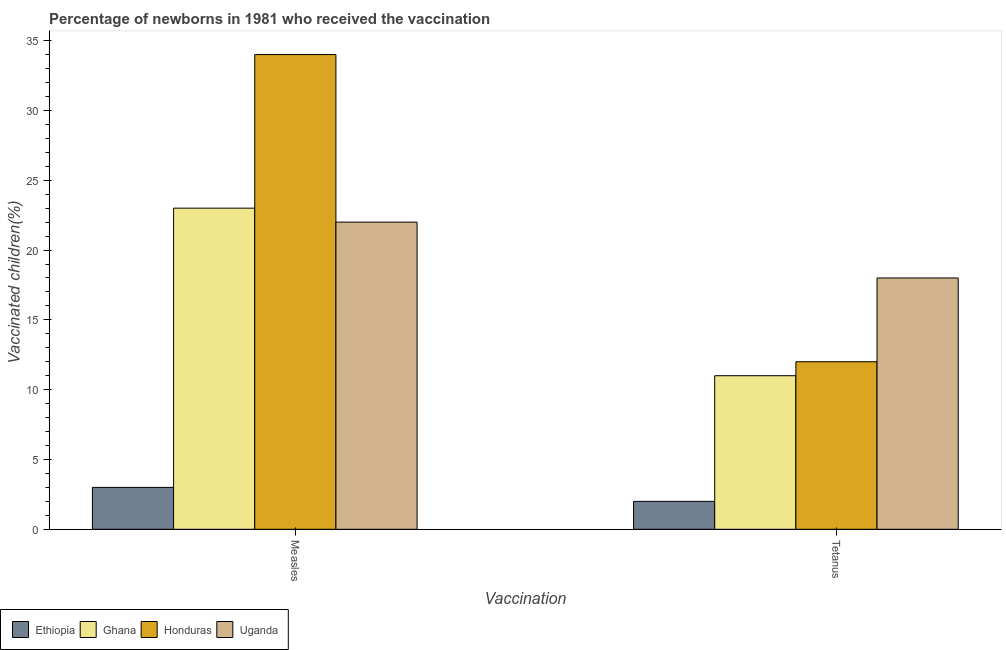How many different coloured bars are there?
Your answer should be compact. 4. Are the number of bars on each tick of the X-axis equal?
Provide a succinct answer. Yes. How many bars are there on the 2nd tick from the right?
Ensure brevity in your answer.  4. What is the label of the 1st group of bars from the left?
Offer a very short reply. Measles. What is the percentage of newborns who received vaccination for tetanus in Uganda?
Offer a very short reply. 18. Across all countries, what is the maximum percentage of newborns who received vaccination for tetanus?
Keep it short and to the point. 18. Across all countries, what is the minimum percentage of newborns who received vaccination for measles?
Your answer should be compact. 3. In which country was the percentage of newborns who received vaccination for measles maximum?
Keep it short and to the point. Honduras. In which country was the percentage of newborns who received vaccination for tetanus minimum?
Your response must be concise. Ethiopia. What is the total percentage of newborns who received vaccination for tetanus in the graph?
Offer a terse response. 43. What is the difference between the percentage of newborns who received vaccination for measles in Ethiopia and that in Ghana?
Your answer should be very brief. -20. What is the difference between the percentage of newborns who received vaccination for measles in Uganda and the percentage of newborns who received vaccination for tetanus in Honduras?
Provide a short and direct response. 10. What is the average percentage of newborns who received vaccination for measles per country?
Provide a succinct answer. 20.5. What is the difference between the percentage of newborns who received vaccination for measles and percentage of newborns who received vaccination for tetanus in Ghana?
Offer a very short reply. 12. What is the ratio of the percentage of newborns who received vaccination for measles in Honduras to that in Ethiopia?
Offer a very short reply. 11.33. Is the percentage of newborns who received vaccination for tetanus in Honduras less than that in Ghana?
Give a very brief answer. No. What does the 1st bar from the left in Tetanus represents?
Ensure brevity in your answer.  Ethiopia. What does the 2nd bar from the right in Measles represents?
Your answer should be very brief. Honduras. How many bars are there?
Offer a terse response. 8. What is the difference between two consecutive major ticks on the Y-axis?
Offer a very short reply. 5. How are the legend labels stacked?
Give a very brief answer. Horizontal. What is the title of the graph?
Ensure brevity in your answer.  Percentage of newborns in 1981 who received the vaccination. Does "Equatorial Guinea" appear as one of the legend labels in the graph?
Offer a terse response. No. What is the label or title of the X-axis?
Keep it short and to the point. Vaccination. What is the label or title of the Y-axis?
Keep it short and to the point. Vaccinated children(%)
. What is the Vaccinated children(%)
 in Ghana in Measles?
Give a very brief answer. 23. What is the Vaccinated children(%)
 in Uganda in Measles?
Your response must be concise. 22. What is the Vaccinated children(%)
 in Ethiopia in Tetanus?
Your answer should be very brief. 2. What is the Vaccinated children(%)
 in Honduras in Tetanus?
Offer a terse response. 12. Across all Vaccination, what is the maximum Vaccinated children(%)
 of Honduras?
Make the answer very short. 34. Across all Vaccination, what is the minimum Vaccinated children(%)
 in Ethiopia?
Give a very brief answer. 2. What is the total Vaccinated children(%)
 in Ethiopia in the graph?
Offer a terse response. 5. What is the total Vaccinated children(%)
 in Uganda in the graph?
Your answer should be compact. 40. What is the difference between the Vaccinated children(%)
 in Ethiopia in Measles and that in Tetanus?
Make the answer very short. 1. What is the difference between the Vaccinated children(%)
 in Ghana in Measles and that in Tetanus?
Make the answer very short. 12. What is the difference between the Vaccinated children(%)
 of Honduras in Measles and that in Tetanus?
Give a very brief answer. 22. What is the difference between the Vaccinated children(%)
 of Ethiopia in Measles and the Vaccinated children(%)
 of Ghana in Tetanus?
Make the answer very short. -8. What is the difference between the Vaccinated children(%)
 in Ethiopia in Measles and the Vaccinated children(%)
 in Honduras in Tetanus?
Give a very brief answer. -9. What is the difference between the Vaccinated children(%)
 in Ghana in Measles and the Vaccinated children(%)
 in Honduras in Tetanus?
Offer a terse response. 11. What is the difference between the Vaccinated children(%)
 of Ghana in Measles and the Vaccinated children(%)
 of Uganda in Tetanus?
Offer a very short reply. 5. What is the difference between the Vaccinated children(%)
 in Ethiopia and Vaccinated children(%)
 in Ghana in Measles?
Your answer should be very brief. -20. What is the difference between the Vaccinated children(%)
 of Ethiopia and Vaccinated children(%)
 of Honduras in Measles?
Provide a short and direct response. -31. What is the difference between the Vaccinated children(%)
 in Honduras and Vaccinated children(%)
 in Uganda in Measles?
Provide a succinct answer. 12. What is the difference between the Vaccinated children(%)
 of Ghana and Vaccinated children(%)
 of Honduras in Tetanus?
Ensure brevity in your answer.  -1. What is the ratio of the Vaccinated children(%)
 of Ethiopia in Measles to that in Tetanus?
Ensure brevity in your answer.  1.5. What is the ratio of the Vaccinated children(%)
 in Ghana in Measles to that in Tetanus?
Offer a very short reply. 2.09. What is the ratio of the Vaccinated children(%)
 of Honduras in Measles to that in Tetanus?
Give a very brief answer. 2.83. What is the ratio of the Vaccinated children(%)
 of Uganda in Measles to that in Tetanus?
Make the answer very short. 1.22. What is the difference between the highest and the second highest Vaccinated children(%)
 of Ethiopia?
Ensure brevity in your answer.  1. What is the difference between the highest and the second highest Vaccinated children(%)
 of Ghana?
Provide a succinct answer. 12. What is the difference between the highest and the second highest Vaccinated children(%)
 of Uganda?
Make the answer very short. 4. What is the difference between the highest and the lowest Vaccinated children(%)
 of Uganda?
Offer a very short reply. 4. 